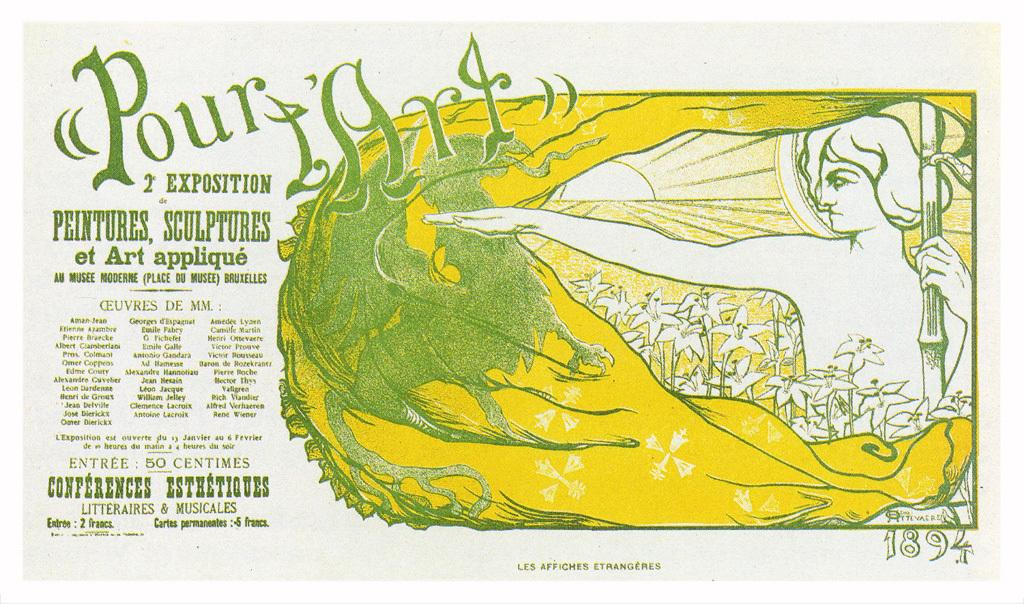What is featured in the picture? There is a poster in the picture. What can be found on the poster? The poster contains text and a picture. What type of plot can be seen in the wilderness in the image? There is no wilderness or plot present in the image; it features a poster with text and a picture. 